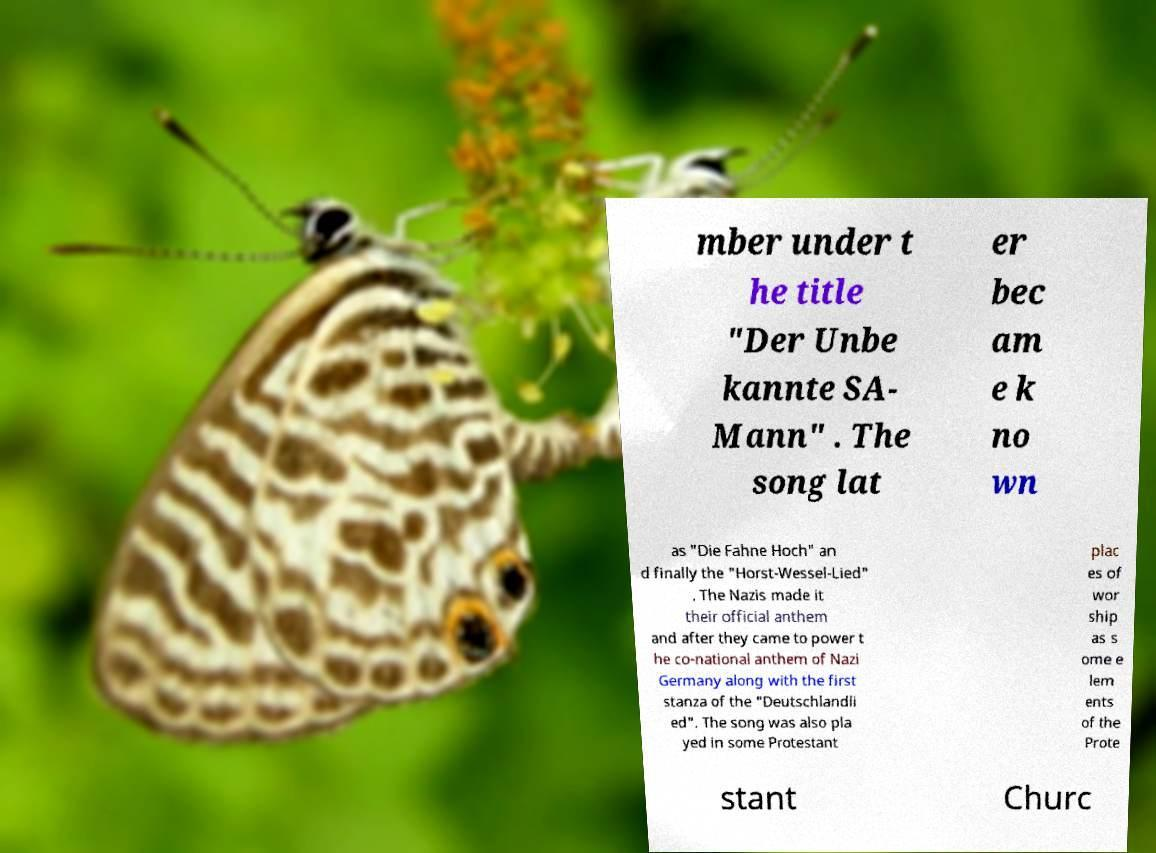What messages or text are displayed in this image? I need them in a readable, typed format. mber under t he title "Der Unbe kannte SA- Mann" . The song lat er bec am e k no wn as "Die Fahne Hoch" an d finally the "Horst-Wessel-Lied" . The Nazis made it their official anthem and after they came to power t he co-national anthem of Nazi Germany along with the first stanza of the "Deutschlandli ed". The song was also pla yed in some Protestant plac es of wor ship as s ome e lem ents of the Prote stant Churc 